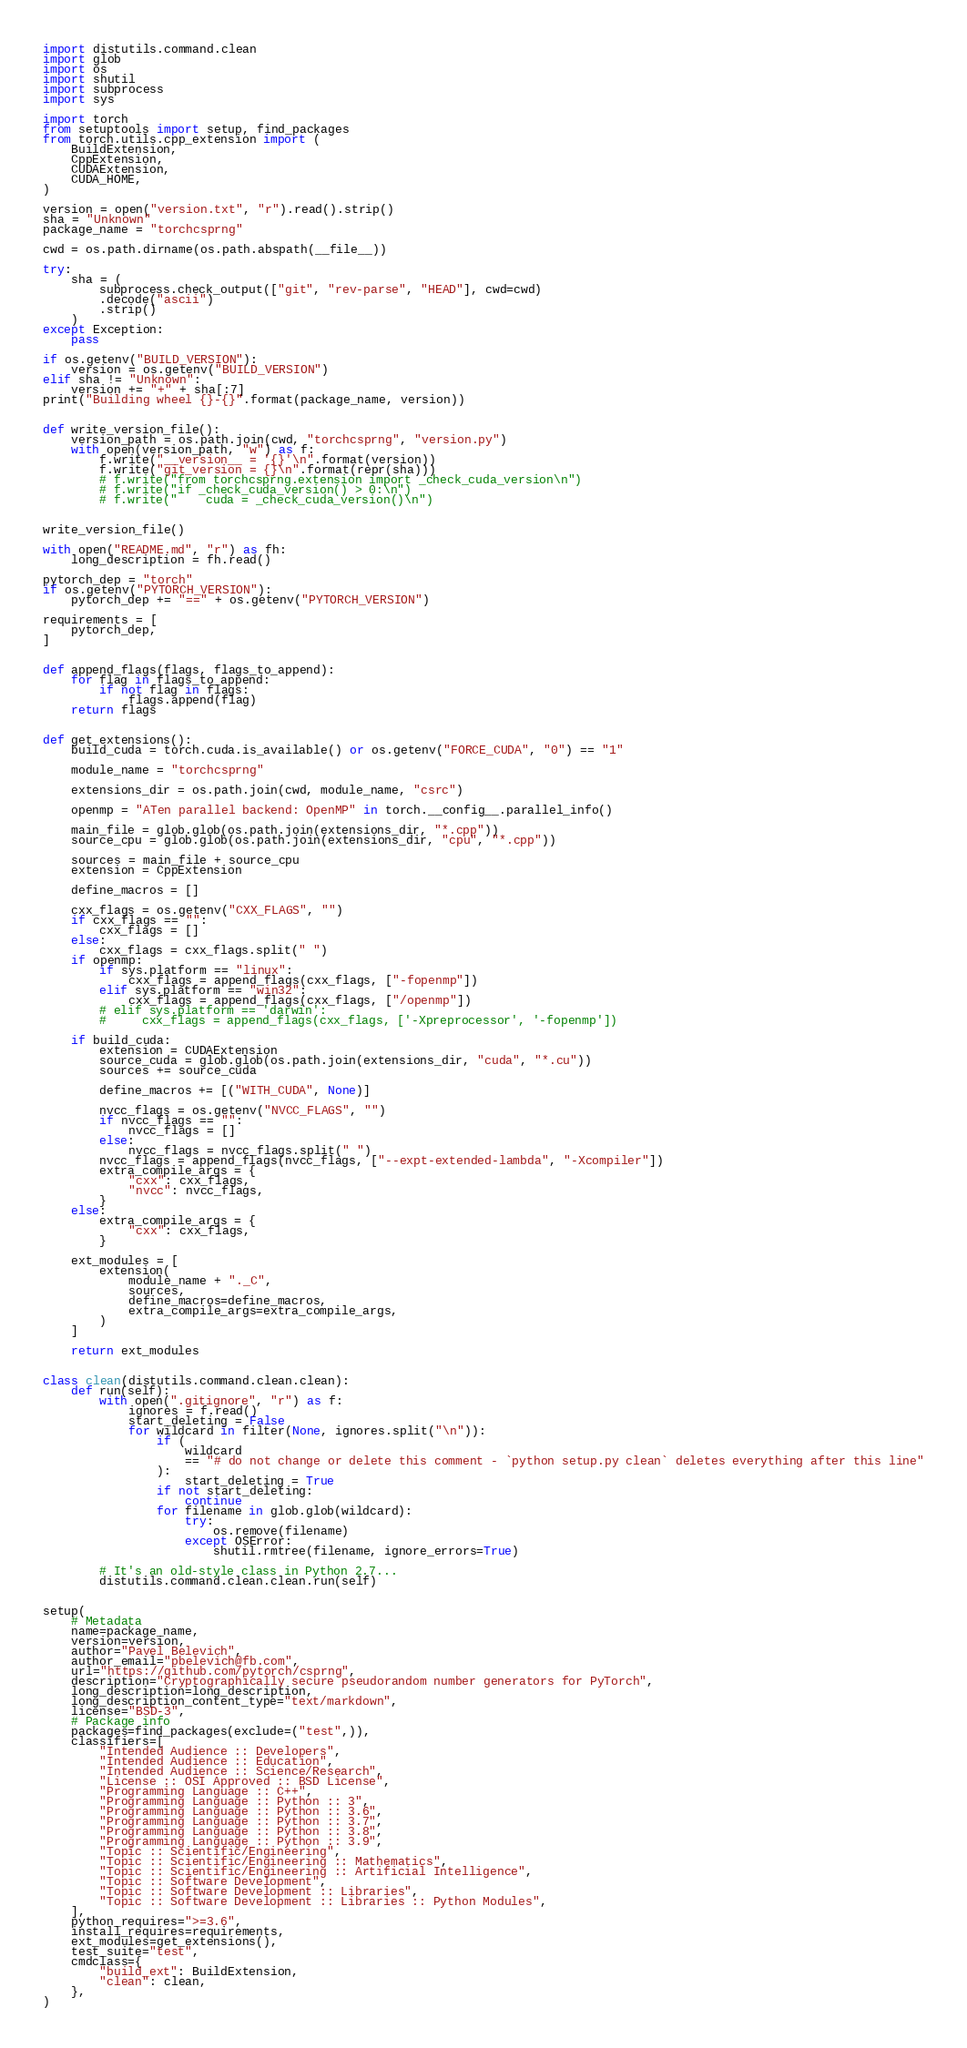Convert code to text. <code><loc_0><loc_0><loc_500><loc_500><_Python_>import distutils.command.clean
import glob
import os
import shutil
import subprocess
import sys

import torch
from setuptools import setup, find_packages
from torch.utils.cpp_extension import (
    BuildExtension,
    CppExtension,
    CUDAExtension,
    CUDA_HOME,
)

version = open("version.txt", "r").read().strip()
sha = "Unknown"
package_name = "torchcsprng"

cwd = os.path.dirname(os.path.abspath(__file__))

try:
    sha = (
        subprocess.check_output(["git", "rev-parse", "HEAD"], cwd=cwd)
        .decode("ascii")
        .strip()
    )
except Exception:
    pass

if os.getenv("BUILD_VERSION"):
    version = os.getenv("BUILD_VERSION")
elif sha != "Unknown":
    version += "+" + sha[:7]
print("Building wheel {}-{}".format(package_name, version))


def write_version_file():
    version_path = os.path.join(cwd, "torchcsprng", "version.py")
    with open(version_path, "w") as f:
        f.write("__version__ = '{}'\n".format(version))
        f.write("git_version = {}\n".format(repr(sha)))
        # f.write("from torchcsprng.extension import _check_cuda_version\n")
        # f.write("if _check_cuda_version() > 0:\n")
        # f.write("    cuda = _check_cuda_version()\n")


write_version_file()

with open("README.md", "r") as fh:
    long_description = fh.read()

pytorch_dep = "torch"
if os.getenv("PYTORCH_VERSION"):
    pytorch_dep += "==" + os.getenv("PYTORCH_VERSION")

requirements = [
    pytorch_dep,
]


def append_flags(flags, flags_to_append):
    for flag in flags_to_append:
        if not flag in flags:
            flags.append(flag)
    return flags


def get_extensions():
    build_cuda = torch.cuda.is_available() or os.getenv("FORCE_CUDA", "0") == "1"

    module_name = "torchcsprng"

    extensions_dir = os.path.join(cwd, module_name, "csrc")

    openmp = "ATen parallel backend: OpenMP" in torch.__config__.parallel_info()

    main_file = glob.glob(os.path.join(extensions_dir, "*.cpp"))
    source_cpu = glob.glob(os.path.join(extensions_dir, "cpu", "*.cpp"))

    sources = main_file + source_cpu
    extension = CppExtension

    define_macros = []

    cxx_flags = os.getenv("CXX_FLAGS", "")
    if cxx_flags == "":
        cxx_flags = []
    else:
        cxx_flags = cxx_flags.split(" ")
    if openmp:
        if sys.platform == "linux":
            cxx_flags = append_flags(cxx_flags, ["-fopenmp"])
        elif sys.platform == "win32":
            cxx_flags = append_flags(cxx_flags, ["/openmp"])
        # elif sys.platform == 'darwin':
        #     cxx_flags = append_flags(cxx_flags, ['-Xpreprocessor', '-fopenmp'])

    if build_cuda:
        extension = CUDAExtension
        source_cuda = glob.glob(os.path.join(extensions_dir, "cuda", "*.cu"))
        sources += source_cuda

        define_macros += [("WITH_CUDA", None)]

        nvcc_flags = os.getenv("NVCC_FLAGS", "")
        if nvcc_flags == "":
            nvcc_flags = []
        else:
            nvcc_flags = nvcc_flags.split(" ")
        nvcc_flags = append_flags(nvcc_flags, ["--expt-extended-lambda", "-Xcompiler"])
        extra_compile_args = {
            "cxx": cxx_flags,
            "nvcc": nvcc_flags,
        }
    else:
        extra_compile_args = {
            "cxx": cxx_flags,
        }

    ext_modules = [
        extension(
            module_name + "._C",
            sources,
            define_macros=define_macros,
            extra_compile_args=extra_compile_args,
        )
    ]

    return ext_modules


class clean(distutils.command.clean.clean):
    def run(self):
        with open(".gitignore", "r") as f:
            ignores = f.read()
            start_deleting = False
            for wildcard in filter(None, ignores.split("\n")):
                if (
                    wildcard
                    == "# do not change or delete this comment - `python setup.py clean` deletes everything after this line"
                ):
                    start_deleting = True
                if not start_deleting:
                    continue
                for filename in glob.glob(wildcard):
                    try:
                        os.remove(filename)
                    except OSError:
                        shutil.rmtree(filename, ignore_errors=True)

        # It's an old-style class in Python 2.7...
        distutils.command.clean.clean.run(self)


setup(
    # Metadata
    name=package_name,
    version=version,
    author="Pavel Belevich",
    author_email="pbelevich@fb.com",
    url="https://github.com/pytorch/csprng",
    description="Cryptographically secure pseudorandom number generators for PyTorch",
    long_description=long_description,
    long_description_content_type="text/markdown",
    license="BSD-3",
    # Package info
    packages=find_packages(exclude=("test",)),
    classifiers=[
        "Intended Audience :: Developers",
        "Intended Audience :: Education",
        "Intended Audience :: Science/Research",
        "License :: OSI Approved :: BSD License",
        "Programming Language :: C++",
        "Programming Language :: Python :: 3",
        "Programming Language :: Python :: 3.6",
        "Programming Language :: Python :: 3.7",
        "Programming Language :: Python :: 3.8",
        "Programming Language :: Python :: 3.9",
        "Topic :: Scientific/Engineering",
        "Topic :: Scientific/Engineering :: Mathematics",
        "Topic :: Scientific/Engineering :: Artificial Intelligence",
        "Topic :: Software Development",
        "Topic :: Software Development :: Libraries",
        "Topic :: Software Development :: Libraries :: Python Modules",
    ],
    python_requires=">=3.6",
    install_requires=requirements,
    ext_modules=get_extensions(),
    test_suite="test",
    cmdclass={
        "build_ext": BuildExtension,
        "clean": clean,
    },
)
</code> 